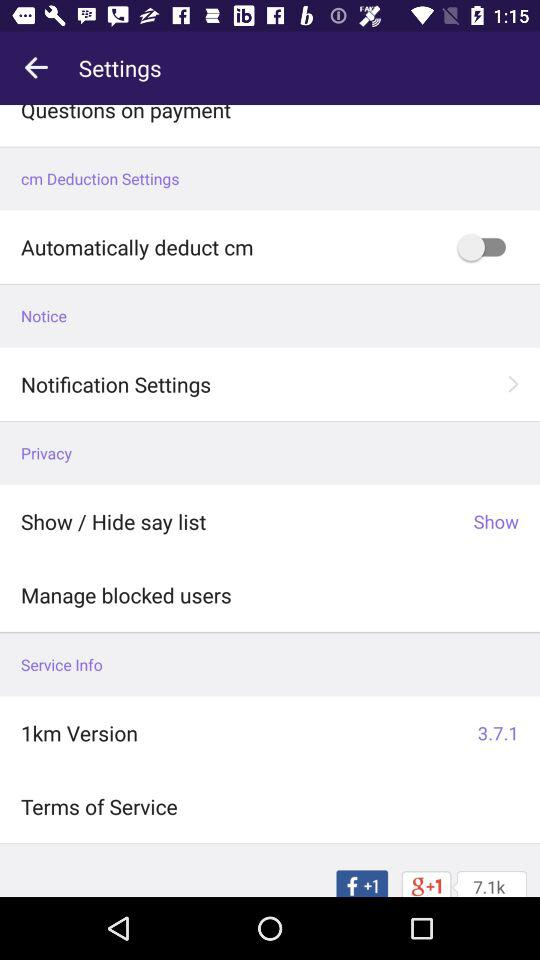What is the setting for "Show / Hide say list"? The setting for "Show / Hide say list" is "Show". 